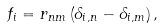Convert formula to latex. <formula><loc_0><loc_0><loc_500><loc_500>f _ { i } = r _ { n m } \left ( \delta _ { i , n } - \delta _ { i , m } \right ) ,</formula> 